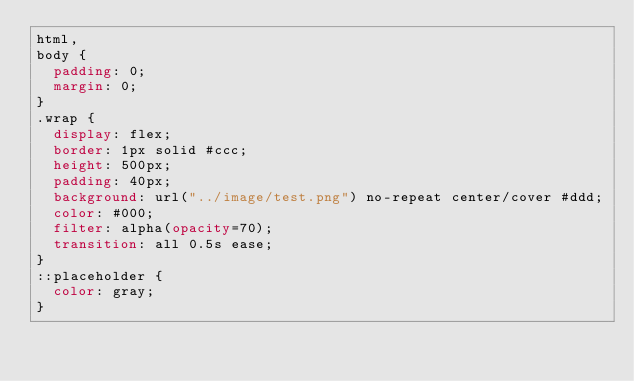Convert code to text. <code><loc_0><loc_0><loc_500><loc_500><_CSS_>html,
body {
  padding: 0;
  margin: 0;
}
.wrap {
  display: flex;
  border: 1px solid #ccc;
  height: 500px;
  padding: 40px;
  background: url("../image/test.png") no-repeat center/cover #ddd;
  color: #000;
  filter: alpha(opacity=70);
  transition: all 0.5s ease;
}
::placeholder {
  color: gray;
}
</code> 